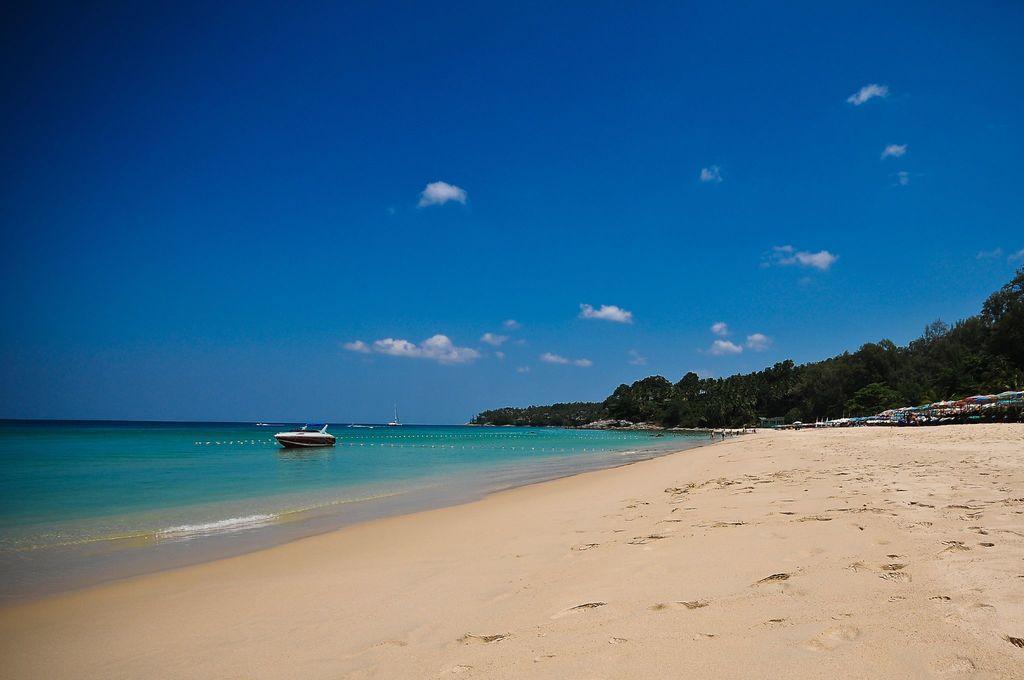Please provide a concise description of this image. As we can see in the image there is sand, water, boat, trees, few people here and there, sky and clouds. 